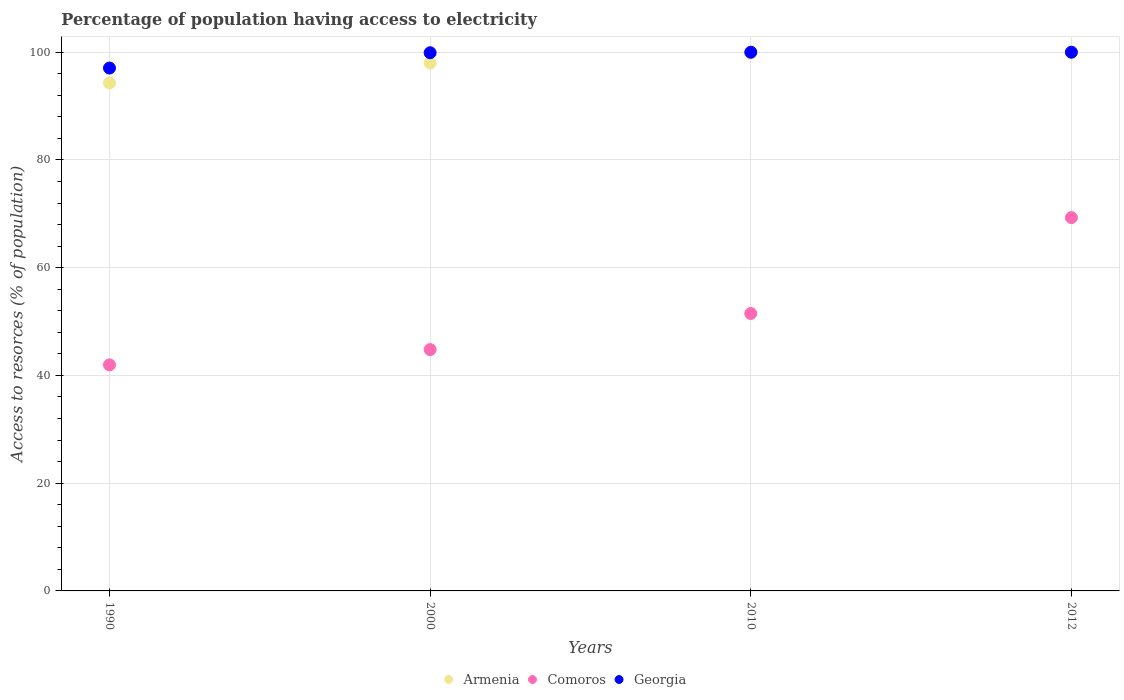Is the number of dotlines equal to the number of legend labels?
Offer a very short reply. Yes. What is the percentage of population having access to electricity in Armenia in 2010?
Make the answer very short. 99.8. Across all years, what is the minimum percentage of population having access to electricity in Georgia?
Offer a terse response. 97.06. In which year was the percentage of population having access to electricity in Georgia minimum?
Offer a terse response. 1990. What is the total percentage of population having access to electricity in Comoros in the graph?
Provide a short and direct response. 207.56. What is the difference between the percentage of population having access to electricity in Comoros in 1990 and that in 2000?
Ensure brevity in your answer.  -2.84. What is the difference between the percentage of population having access to electricity in Armenia in 2010 and the percentage of population having access to electricity in Georgia in 2012?
Provide a short and direct response. -0.2. What is the average percentage of population having access to electricity in Georgia per year?
Keep it short and to the point. 99.24. In the year 2000, what is the difference between the percentage of population having access to electricity in Comoros and percentage of population having access to electricity in Armenia?
Ensure brevity in your answer.  -53.2. What is the ratio of the percentage of population having access to electricity in Comoros in 2000 to that in 2012?
Ensure brevity in your answer.  0.65. Is the percentage of population having access to electricity in Georgia in 2000 less than that in 2012?
Make the answer very short. Yes. What is the difference between the highest and the second highest percentage of population having access to electricity in Armenia?
Provide a succinct answer. 0.2. What is the difference between the highest and the lowest percentage of population having access to electricity in Georgia?
Give a very brief answer. 2.94. In how many years, is the percentage of population having access to electricity in Georgia greater than the average percentage of population having access to electricity in Georgia taken over all years?
Keep it short and to the point. 3. Is the percentage of population having access to electricity in Georgia strictly greater than the percentage of population having access to electricity in Comoros over the years?
Your answer should be very brief. Yes. Is the percentage of population having access to electricity in Comoros strictly less than the percentage of population having access to electricity in Armenia over the years?
Offer a very short reply. Yes. How many dotlines are there?
Offer a terse response. 3. How many years are there in the graph?
Give a very brief answer. 4. What is the difference between two consecutive major ticks on the Y-axis?
Give a very brief answer. 20. Does the graph contain any zero values?
Your response must be concise. No. Does the graph contain grids?
Your response must be concise. Yes. How many legend labels are there?
Your answer should be very brief. 3. How are the legend labels stacked?
Offer a terse response. Horizontal. What is the title of the graph?
Your answer should be compact. Percentage of population having access to electricity. What is the label or title of the Y-axis?
Your answer should be very brief. Access to resorces (% of population). What is the Access to resorces (% of population) in Armenia in 1990?
Offer a very short reply. 94.29. What is the Access to resorces (% of population) of Comoros in 1990?
Your response must be concise. 41.96. What is the Access to resorces (% of population) of Georgia in 1990?
Ensure brevity in your answer.  97.06. What is the Access to resorces (% of population) of Comoros in 2000?
Ensure brevity in your answer.  44.8. What is the Access to resorces (% of population) in Georgia in 2000?
Provide a short and direct response. 99.9. What is the Access to resorces (% of population) of Armenia in 2010?
Provide a short and direct response. 99.8. What is the Access to resorces (% of population) in Comoros in 2010?
Keep it short and to the point. 51.5. What is the Access to resorces (% of population) in Comoros in 2012?
Offer a terse response. 69.3. What is the Access to resorces (% of population) in Georgia in 2012?
Your answer should be very brief. 100. Across all years, what is the maximum Access to resorces (% of population) of Comoros?
Your answer should be compact. 69.3. Across all years, what is the maximum Access to resorces (% of population) in Georgia?
Offer a very short reply. 100. Across all years, what is the minimum Access to resorces (% of population) of Armenia?
Provide a short and direct response. 94.29. Across all years, what is the minimum Access to resorces (% of population) of Comoros?
Your answer should be compact. 41.96. Across all years, what is the minimum Access to resorces (% of population) in Georgia?
Make the answer very short. 97.06. What is the total Access to resorces (% of population) in Armenia in the graph?
Give a very brief answer. 392.09. What is the total Access to resorces (% of population) in Comoros in the graph?
Offer a very short reply. 207.56. What is the total Access to resorces (% of population) in Georgia in the graph?
Your response must be concise. 396.96. What is the difference between the Access to resorces (% of population) of Armenia in 1990 and that in 2000?
Your answer should be very brief. -3.71. What is the difference between the Access to resorces (% of population) in Comoros in 1990 and that in 2000?
Offer a very short reply. -2.84. What is the difference between the Access to resorces (% of population) of Georgia in 1990 and that in 2000?
Ensure brevity in your answer.  -2.84. What is the difference between the Access to resorces (% of population) in Armenia in 1990 and that in 2010?
Your response must be concise. -5.51. What is the difference between the Access to resorces (% of population) in Comoros in 1990 and that in 2010?
Provide a short and direct response. -9.54. What is the difference between the Access to resorces (% of population) in Georgia in 1990 and that in 2010?
Offer a terse response. -2.94. What is the difference between the Access to resorces (% of population) of Armenia in 1990 and that in 2012?
Provide a short and direct response. -5.71. What is the difference between the Access to resorces (% of population) of Comoros in 1990 and that in 2012?
Provide a succinct answer. -27.34. What is the difference between the Access to resorces (% of population) in Georgia in 1990 and that in 2012?
Your response must be concise. -2.94. What is the difference between the Access to resorces (% of population) of Armenia in 2000 and that in 2010?
Offer a terse response. -1.8. What is the difference between the Access to resorces (% of population) of Georgia in 2000 and that in 2010?
Ensure brevity in your answer.  -0.1. What is the difference between the Access to resorces (% of population) of Comoros in 2000 and that in 2012?
Offer a very short reply. -24.5. What is the difference between the Access to resorces (% of population) in Armenia in 2010 and that in 2012?
Your answer should be compact. -0.2. What is the difference between the Access to resorces (% of population) of Comoros in 2010 and that in 2012?
Ensure brevity in your answer.  -17.8. What is the difference between the Access to resorces (% of population) in Georgia in 2010 and that in 2012?
Ensure brevity in your answer.  0. What is the difference between the Access to resorces (% of population) in Armenia in 1990 and the Access to resorces (% of population) in Comoros in 2000?
Make the answer very short. 49.49. What is the difference between the Access to resorces (% of population) in Armenia in 1990 and the Access to resorces (% of population) in Georgia in 2000?
Your answer should be very brief. -5.61. What is the difference between the Access to resorces (% of population) in Comoros in 1990 and the Access to resorces (% of population) in Georgia in 2000?
Your response must be concise. -57.94. What is the difference between the Access to resorces (% of population) in Armenia in 1990 and the Access to resorces (% of population) in Comoros in 2010?
Your answer should be very brief. 42.79. What is the difference between the Access to resorces (% of population) in Armenia in 1990 and the Access to resorces (% of population) in Georgia in 2010?
Your answer should be very brief. -5.71. What is the difference between the Access to resorces (% of population) of Comoros in 1990 and the Access to resorces (% of population) of Georgia in 2010?
Offer a terse response. -58.04. What is the difference between the Access to resorces (% of population) of Armenia in 1990 and the Access to resorces (% of population) of Comoros in 2012?
Make the answer very short. 24.99. What is the difference between the Access to resorces (% of population) of Armenia in 1990 and the Access to resorces (% of population) of Georgia in 2012?
Provide a short and direct response. -5.71. What is the difference between the Access to resorces (% of population) of Comoros in 1990 and the Access to resorces (% of population) of Georgia in 2012?
Offer a terse response. -58.04. What is the difference between the Access to resorces (% of population) of Armenia in 2000 and the Access to resorces (% of population) of Comoros in 2010?
Provide a succinct answer. 46.5. What is the difference between the Access to resorces (% of population) in Comoros in 2000 and the Access to resorces (% of population) in Georgia in 2010?
Provide a succinct answer. -55.2. What is the difference between the Access to resorces (% of population) in Armenia in 2000 and the Access to resorces (% of population) in Comoros in 2012?
Keep it short and to the point. 28.7. What is the difference between the Access to resorces (% of population) of Armenia in 2000 and the Access to resorces (% of population) of Georgia in 2012?
Give a very brief answer. -2. What is the difference between the Access to resorces (% of population) of Comoros in 2000 and the Access to resorces (% of population) of Georgia in 2012?
Give a very brief answer. -55.2. What is the difference between the Access to resorces (% of population) in Armenia in 2010 and the Access to resorces (% of population) in Comoros in 2012?
Your answer should be very brief. 30.5. What is the difference between the Access to resorces (% of population) in Comoros in 2010 and the Access to resorces (% of population) in Georgia in 2012?
Your answer should be very brief. -48.5. What is the average Access to resorces (% of population) in Armenia per year?
Keep it short and to the point. 98.02. What is the average Access to resorces (% of population) of Comoros per year?
Keep it short and to the point. 51.89. What is the average Access to resorces (% of population) in Georgia per year?
Your response must be concise. 99.24. In the year 1990, what is the difference between the Access to resorces (% of population) in Armenia and Access to resorces (% of population) in Comoros?
Your answer should be very brief. 52.33. In the year 1990, what is the difference between the Access to resorces (% of population) of Armenia and Access to resorces (% of population) of Georgia?
Offer a terse response. -2.77. In the year 1990, what is the difference between the Access to resorces (% of population) in Comoros and Access to resorces (% of population) in Georgia?
Offer a terse response. -55.1. In the year 2000, what is the difference between the Access to resorces (% of population) in Armenia and Access to resorces (% of population) in Comoros?
Your response must be concise. 53.2. In the year 2000, what is the difference between the Access to resorces (% of population) of Comoros and Access to resorces (% of population) of Georgia?
Make the answer very short. -55.1. In the year 2010, what is the difference between the Access to resorces (% of population) in Armenia and Access to resorces (% of population) in Comoros?
Keep it short and to the point. 48.3. In the year 2010, what is the difference between the Access to resorces (% of population) in Comoros and Access to resorces (% of population) in Georgia?
Keep it short and to the point. -48.5. In the year 2012, what is the difference between the Access to resorces (% of population) in Armenia and Access to resorces (% of population) in Comoros?
Provide a succinct answer. 30.7. In the year 2012, what is the difference between the Access to resorces (% of population) in Comoros and Access to resorces (% of population) in Georgia?
Your answer should be very brief. -30.7. What is the ratio of the Access to resorces (% of population) of Armenia in 1990 to that in 2000?
Provide a succinct answer. 0.96. What is the ratio of the Access to resorces (% of population) in Comoros in 1990 to that in 2000?
Provide a succinct answer. 0.94. What is the ratio of the Access to resorces (% of population) of Georgia in 1990 to that in 2000?
Keep it short and to the point. 0.97. What is the ratio of the Access to resorces (% of population) in Armenia in 1990 to that in 2010?
Provide a succinct answer. 0.94. What is the ratio of the Access to resorces (% of population) of Comoros in 1990 to that in 2010?
Your response must be concise. 0.81. What is the ratio of the Access to resorces (% of population) of Georgia in 1990 to that in 2010?
Provide a short and direct response. 0.97. What is the ratio of the Access to resorces (% of population) of Armenia in 1990 to that in 2012?
Provide a succinct answer. 0.94. What is the ratio of the Access to resorces (% of population) of Comoros in 1990 to that in 2012?
Keep it short and to the point. 0.61. What is the ratio of the Access to resorces (% of population) of Georgia in 1990 to that in 2012?
Provide a short and direct response. 0.97. What is the ratio of the Access to resorces (% of population) of Armenia in 2000 to that in 2010?
Your response must be concise. 0.98. What is the ratio of the Access to resorces (% of population) in Comoros in 2000 to that in 2010?
Give a very brief answer. 0.87. What is the ratio of the Access to resorces (% of population) in Comoros in 2000 to that in 2012?
Offer a terse response. 0.65. What is the ratio of the Access to resorces (% of population) of Comoros in 2010 to that in 2012?
Give a very brief answer. 0.74. What is the ratio of the Access to resorces (% of population) of Georgia in 2010 to that in 2012?
Offer a terse response. 1. What is the difference between the highest and the second highest Access to resorces (% of population) in Armenia?
Your response must be concise. 0.2. What is the difference between the highest and the second highest Access to resorces (% of population) of Georgia?
Give a very brief answer. 0. What is the difference between the highest and the lowest Access to resorces (% of population) in Armenia?
Your answer should be very brief. 5.71. What is the difference between the highest and the lowest Access to resorces (% of population) in Comoros?
Your answer should be compact. 27.34. What is the difference between the highest and the lowest Access to resorces (% of population) in Georgia?
Give a very brief answer. 2.94. 